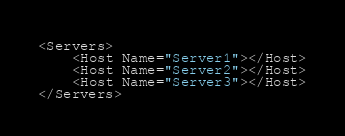Convert code to text. <code><loc_0><loc_0><loc_500><loc_500><_XML_><Servers>
    <Host Name="Server1"></Host>
    <Host Name="Server2"></Host>
    <Host Name="Server3"></Host>
</Servers></code> 